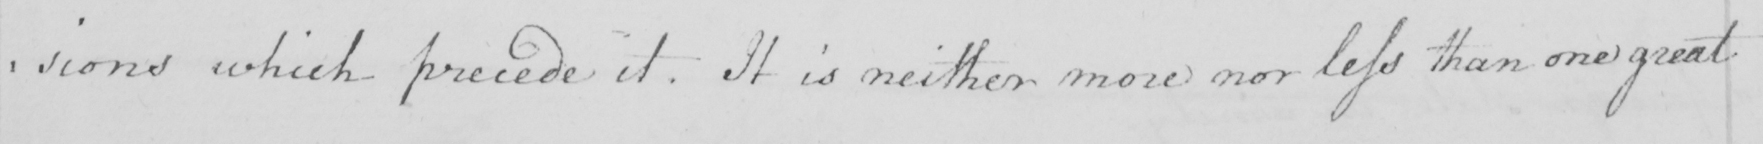What is written in this line of handwriting? -isions which precede it . It is neither more nor less than one great 